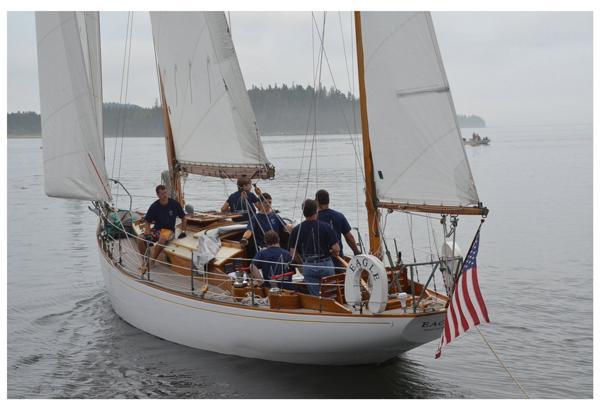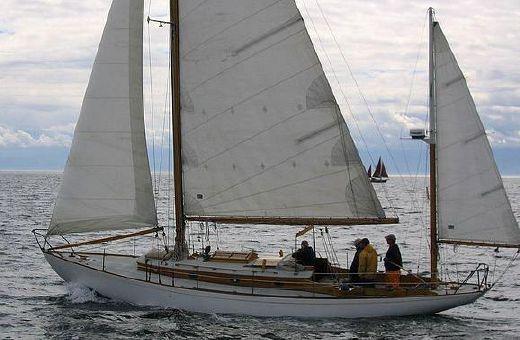The first image is the image on the left, the second image is the image on the right. For the images shown, is this caption "Neither boat has its sails up." true? Answer yes or no. No. 